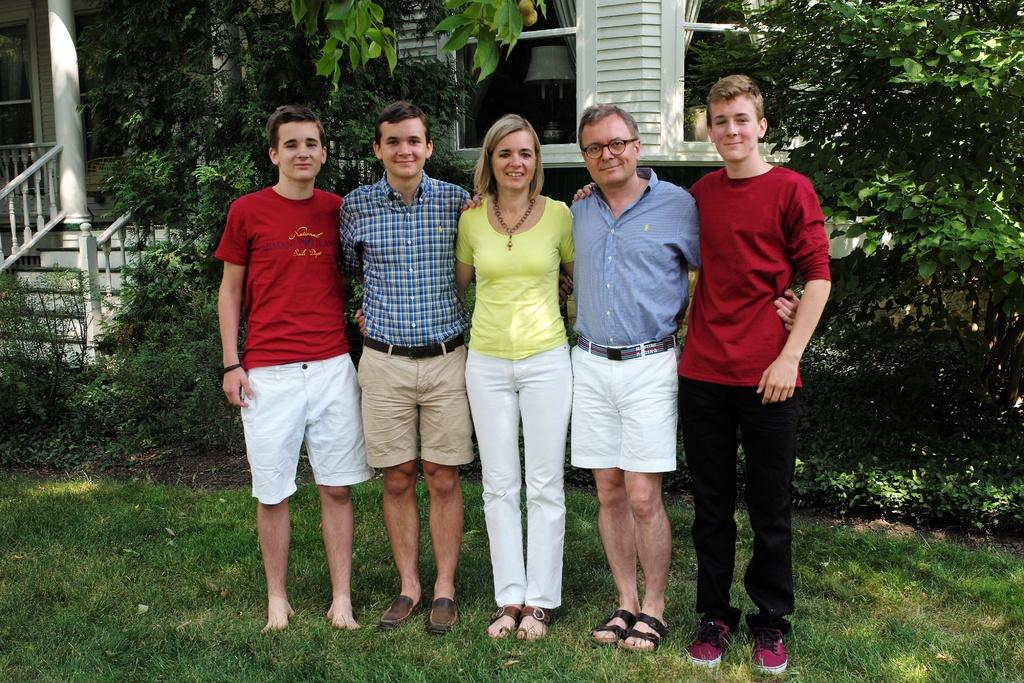How many people are present in the image? There are five persons standing on the ground. What is the ground covered with? The ground is covered with grass. What type of vegetation can be seen in the image? There are plants and trees in the image. What structure is visible in the background of the image? There is a house in the background of the image. What type of expansion is taking place in the image? There is no indication of any expansion occurring in the image. What process can be observed being carried out by the dolls in the image? There are no dolls present in the image, so no such process can be observed. 